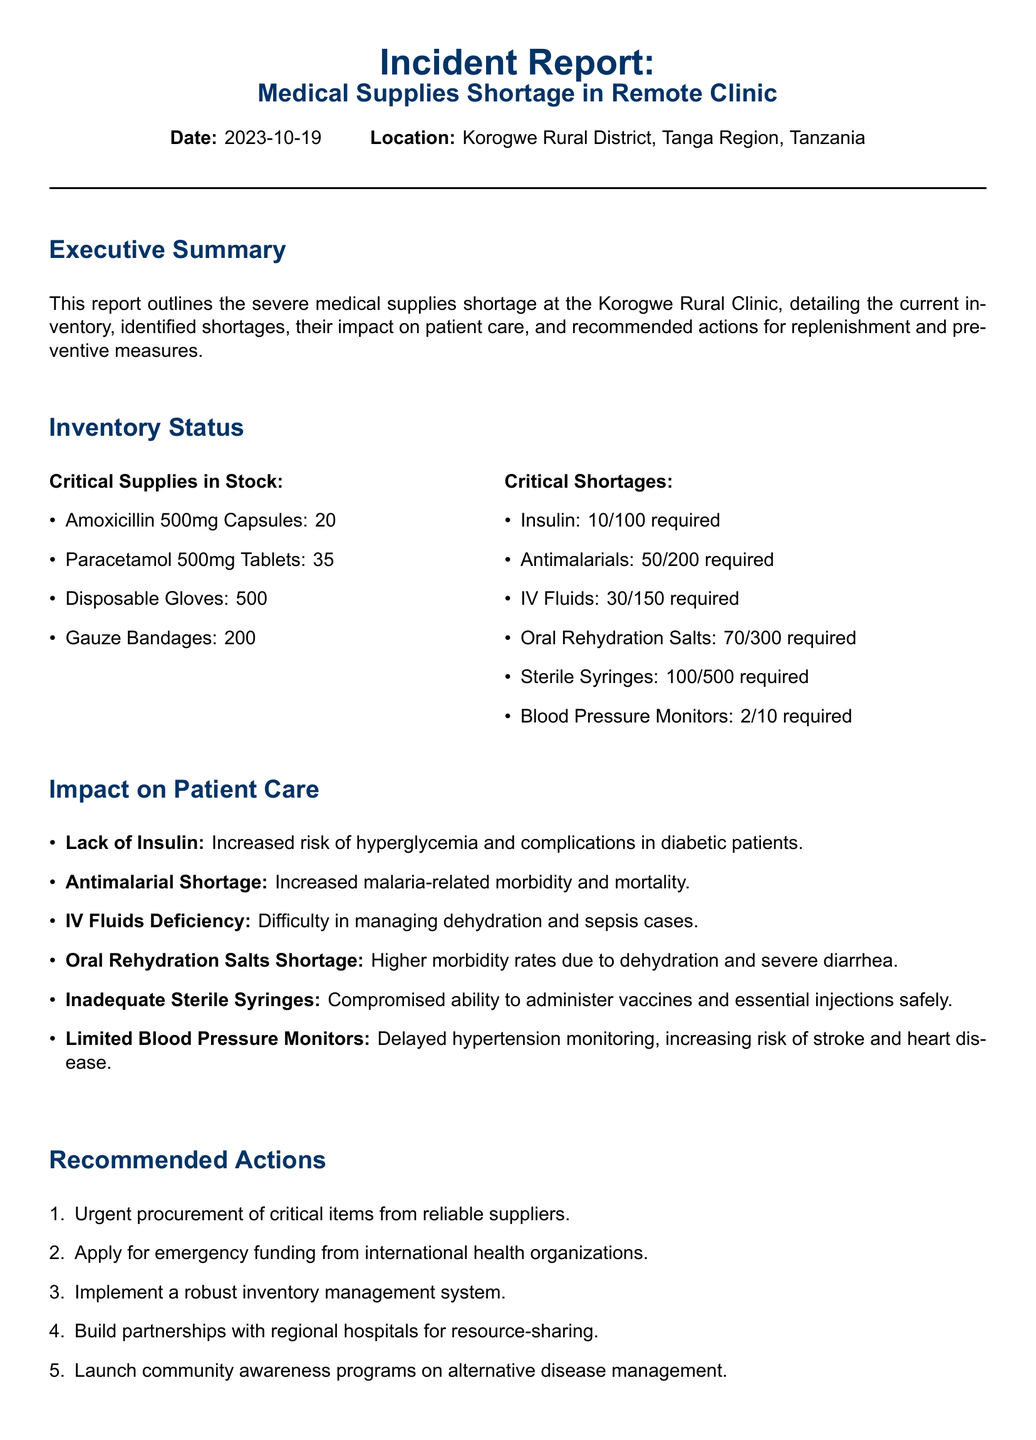What is the date of the incident report? The date is mentioned at the beginning of the report under the "Date" section.
Answer: 2023-10-19 What is the location of the medical supplies shortage? The location is stated in the report, specifically in the header section.
Answer: Korogwe Rural District, Tanga Region, Tanzania How many sterile syringes are currently in stock? The inventory status section lists the current stock of each critical supply, including sterile syringes.
Answer: 400 What is the number of insulin units required? The report details the requirements for insulin in the "Critical Shortages" section.
Answer: 90 What impact does the shortage of antimalarials have on patient care? The impact is described under the "Impact on Patient Care" section, specifically relating to antimalarials.
Answer: Increased malaria-related morbidity and mortality What is one recommended action for replenishment? The recommended actions are listed in the "Recommended Actions" section of the report.
Answer: Urgent procurement of critical items What is one preventive measure suggested in the report? Preventive measures are outlined in the appropriate section; one can be identified.
Answer: Regular supply chain audits How many IV fluids are required? This information is found in the "Critical Shortages" section where IV fluids are listed.
Answer: 120 What type of organization prepared this report? The publisher of the report is noted at the end, indicating the type of organization involved.
Answer: Global Health Outreach 